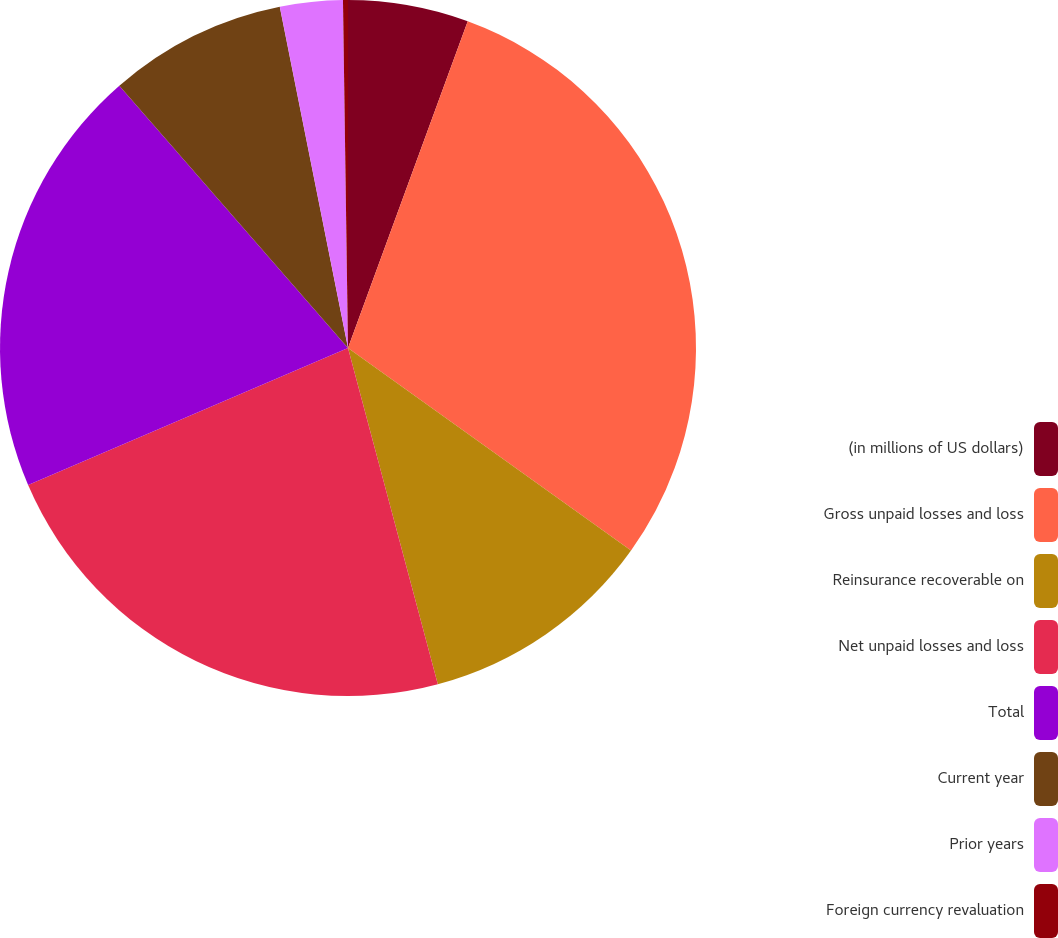<chart> <loc_0><loc_0><loc_500><loc_500><pie_chart><fcel>(in millions of US dollars)<fcel>Gross unpaid losses and loss<fcel>Reinsurance recoverable on<fcel>Net unpaid losses and loss<fcel>Total<fcel>Current year<fcel>Prior years<fcel>Foreign currency revaluation<nl><fcel>5.59%<fcel>29.29%<fcel>10.96%<fcel>22.71%<fcel>20.03%<fcel>8.27%<fcel>2.91%<fcel>0.23%<nl></chart> 